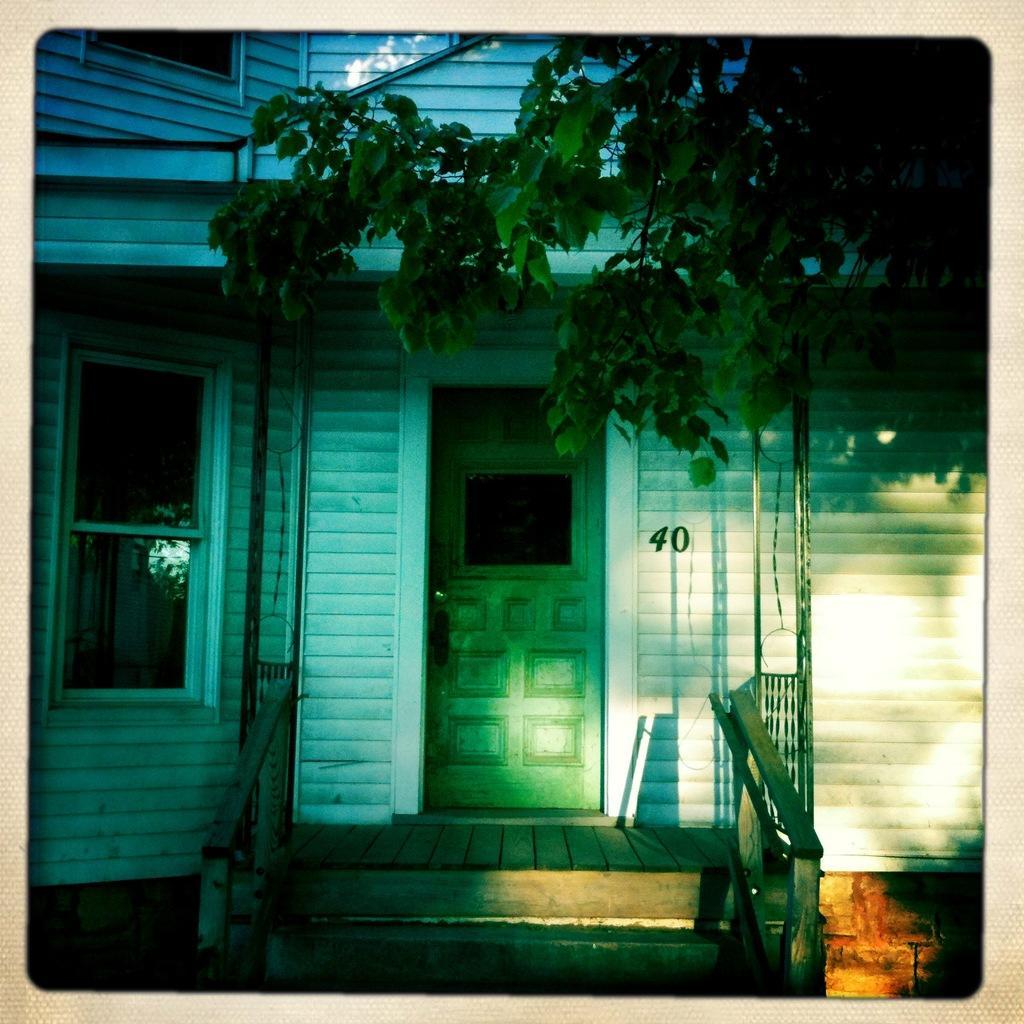Please provide a concise description of this image. In this image I can see a house with a window and a door. In top right corner, I can see a tree. 